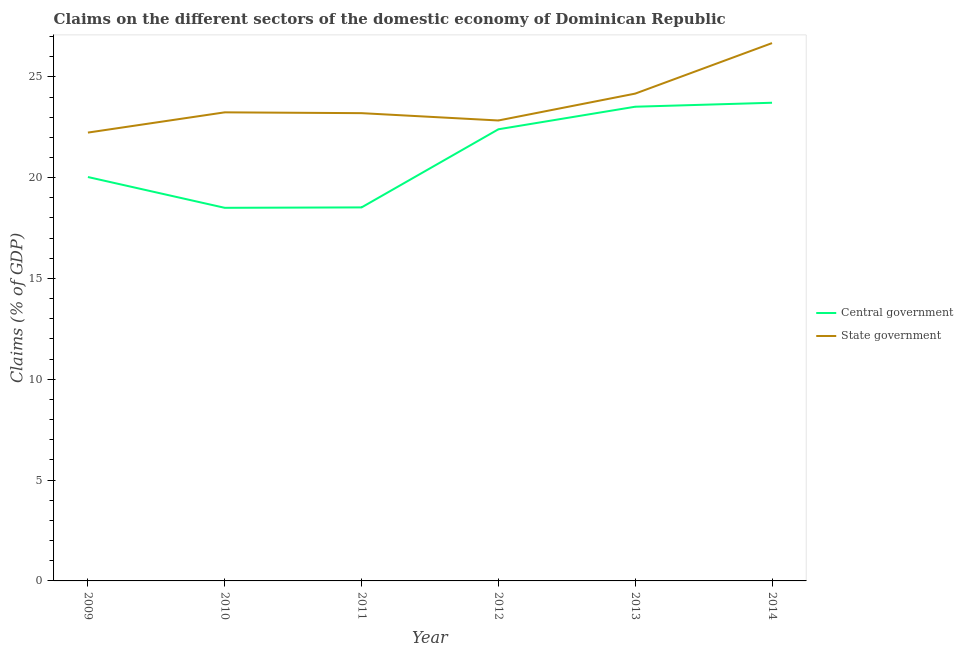Does the line corresponding to claims on central government intersect with the line corresponding to claims on state government?
Provide a short and direct response. No. Is the number of lines equal to the number of legend labels?
Your answer should be compact. Yes. What is the claims on central government in 2011?
Give a very brief answer. 18.52. Across all years, what is the maximum claims on central government?
Keep it short and to the point. 23.71. Across all years, what is the minimum claims on state government?
Your answer should be very brief. 22.24. What is the total claims on central government in the graph?
Your response must be concise. 126.69. What is the difference between the claims on central government in 2010 and that in 2011?
Provide a short and direct response. -0.02. What is the difference between the claims on central government in 2011 and the claims on state government in 2013?
Offer a terse response. -5.64. What is the average claims on state government per year?
Offer a very short reply. 23.73. In the year 2011, what is the difference between the claims on central government and claims on state government?
Give a very brief answer. -4.67. What is the ratio of the claims on central government in 2009 to that in 2013?
Give a very brief answer. 0.85. Is the claims on central government in 2012 less than that in 2014?
Provide a short and direct response. Yes. Is the difference between the claims on state government in 2009 and 2011 greater than the difference between the claims on central government in 2009 and 2011?
Keep it short and to the point. No. What is the difference between the highest and the second highest claims on central government?
Your answer should be very brief. 0.2. What is the difference between the highest and the lowest claims on central government?
Provide a short and direct response. 5.21. In how many years, is the claims on state government greater than the average claims on state government taken over all years?
Give a very brief answer. 2. Is the claims on state government strictly greater than the claims on central government over the years?
Your answer should be very brief. Yes. Is the claims on central government strictly less than the claims on state government over the years?
Offer a terse response. Yes. Are the values on the major ticks of Y-axis written in scientific E-notation?
Your answer should be compact. No. Does the graph contain any zero values?
Give a very brief answer. No. Where does the legend appear in the graph?
Keep it short and to the point. Center right. How many legend labels are there?
Your response must be concise. 2. How are the legend labels stacked?
Your response must be concise. Vertical. What is the title of the graph?
Offer a terse response. Claims on the different sectors of the domestic economy of Dominican Republic. Does "DAC donors" appear as one of the legend labels in the graph?
Keep it short and to the point. No. What is the label or title of the X-axis?
Keep it short and to the point. Year. What is the label or title of the Y-axis?
Give a very brief answer. Claims (% of GDP). What is the Claims (% of GDP) of Central government in 2009?
Keep it short and to the point. 20.03. What is the Claims (% of GDP) in State government in 2009?
Your answer should be very brief. 22.24. What is the Claims (% of GDP) in Central government in 2010?
Your answer should be very brief. 18.5. What is the Claims (% of GDP) of State government in 2010?
Offer a very short reply. 23.24. What is the Claims (% of GDP) of Central government in 2011?
Offer a terse response. 18.52. What is the Claims (% of GDP) of State government in 2011?
Your answer should be very brief. 23.2. What is the Claims (% of GDP) in Central government in 2012?
Keep it short and to the point. 22.4. What is the Claims (% of GDP) in State government in 2012?
Ensure brevity in your answer.  22.84. What is the Claims (% of GDP) in Central government in 2013?
Your answer should be compact. 23.52. What is the Claims (% of GDP) in State government in 2013?
Your response must be concise. 24.17. What is the Claims (% of GDP) in Central government in 2014?
Your answer should be very brief. 23.71. What is the Claims (% of GDP) in State government in 2014?
Your response must be concise. 26.67. Across all years, what is the maximum Claims (% of GDP) in Central government?
Provide a short and direct response. 23.71. Across all years, what is the maximum Claims (% of GDP) in State government?
Ensure brevity in your answer.  26.67. Across all years, what is the minimum Claims (% of GDP) in Central government?
Offer a very short reply. 18.5. Across all years, what is the minimum Claims (% of GDP) of State government?
Provide a short and direct response. 22.24. What is the total Claims (% of GDP) in Central government in the graph?
Give a very brief answer. 126.69. What is the total Claims (% of GDP) of State government in the graph?
Make the answer very short. 142.35. What is the difference between the Claims (% of GDP) of Central government in 2009 and that in 2010?
Offer a terse response. 1.53. What is the difference between the Claims (% of GDP) in State government in 2009 and that in 2010?
Your answer should be very brief. -1. What is the difference between the Claims (% of GDP) in Central government in 2009 and that in 2011?
Give a very brief answer. 1.51. What is the difference between the Claims (% of GDP) of State government in 2009 and that in 2011?
Provide a short and direct response. -0.96. What is the difference between the Claims (% of GDP) of Central government in 2009 and that in 2012?
Offer a terse response. -2.37. What is the difference between the Claims (% of GDP) of State government in 2009 and that in 2012?
Make the answer very short. -0.6. What is the difference between the Claims (% of GDP) of Central government in 2009 and that in 2013?
Make the answer very short. -3.49. What is the difference between the Claims (% of GDP) of State government in 2009 and that in 2013?
Offer a terse response. -1.93. What is the difference between the Claims (% of GDP) of Central government in 2009 and that in 2014?
Ensure brevity in your answer.  -3.68. What is the difference between the Claims (% of GDP) of State government in 2009 and that in 2014?
Offer a terse response. -4.44. What is the difference between the Claims (% of GDP) in Central government in 2010 and that in 2011?
Your answer should be compact. -0.02. What is the difference between the Claims (% of GDP) of State government in 2010 and that in 2011?
Offer a terse response. 0.04. What is the difference between the Claims (% of GDP) in Central government in 2010 and that in 2012?
Keep it short and to the point. -3.89. What is the difference between the Claims (% of GDP) in State government in 2010 and that in 2012?
Make the answer very short. 0.4. What is the difference between the Claims (% of GDP) in Central government in 2010 and that in 2013?
Make the answer very short. -5.01. What is the difference between the Claims (% of GDP) in State government in 2010 and that in 2013?
Your answer should be compact. -0.93. What is the difference between the Claims (% of GDP) of Central government in 2010 and that in 2014?
Your response must be concise. -5.21. What is the difference between the Claims (% of GDP) in State government in 2010 and that in 2014?
Make the answer very short. -3.43. What is the difference between the Claims (% of GDP) of Central government in 2011 and that in 2012?
Give a very brief answer. -3.87. What is the difference between the Claims (% of GDP) in State government in 2011 and that in 2012?
Make the answer very short. 0.36. What is the difference between the Claims (% of GDP) of Central government in 2011 and that in 2013?
Your response must be concise. -4.99. What is the difference between the Claims (% of GDP) in State government in 2011 and that in 2013?
Offer a very short reply. -0.97. What is the difference between the Claims (% of GDP) of Central government in 2011 and that in 2014?
Ensure brevity in your answer.  -5.19. What is the difference between the Claims (% of GDP) of State government in 2011 and that in 2014?
Make the answer very short. -3.47. What is the difference between the Claims (% of GDP) of Central government in 2012 and that in 2013?
Provide a short and direct response. -1.12. What is the difference between the Claims (% of GDP) in State government in 2012 and that in 2013?
Your answer should be very brief. -1.33. What is the difference between the Claims (% of GDP) in Central government in 2012 and that in 2014?
Keep it short and to the point. -1.32. What is the difference between the Claims (% of GDP) of State government in 2012 and that in 2014?
Provide a short and direct response. -3.84. What is the difference between the Claims (% of GDP) in Central government in 2013 and that in 2014?
Your response must be concise. -0.2. What is the difference between the Claims (% of GDP) of State government in 2013 and that in 2014?
Your answer should be very brief. -2.5. What is the difference between the Claims (% of GDP) in Central government in 2009 and the Claims (% of GDP) in State government in 2010?
Offer a very short reply. -3.21. What is the difference between the Claims (% of GDP) in Central government in 2009 and the Claims (% of GDP) in State government in 2011?
Give a very brief answer. -3.17. What is the difference between the Claims (% of GDP) of Central government in 2009 and the Claims (% of GDP) of State government in 2012?
Your response must be concise. -2.8. What is the difference between the Claims (% of GDP) of Central government in 2009 and the Claims (% of GDP) of State government in 2013?
Your answer should be very brief. -4.14. What is the difference between the Claims (% of GDP) in Central government in 2009 and the Claims (% of GDP) in State government in 2014?
Offer a terse response. -6.64. What is the difference between the Claims (% of GDP) in Central government in 2010 and the Claims (% of GDP) in State government in 2011?
Your answer should be very brief. -4.69. What is the difference between the Claims (% of GDP) in Central government in 2010 and the Claims (% of GDP) in State government in 2012?
Your response must be concise. -4.33. What is the difference between the Claims (% of GDP) in Central government in 2010 and the Claims (% of GDP) in State government in 2013?
Your answer should be compact. -5.66. What is the difference between the Claims (% of GDP) of Central government in 2010 and the Claims (% of GDP) of State government in 2014?
Keep it short and to the point. -8.17. What is the difference between the Claims (% of GDP) of Central government in 2011 and the Claims (% of GDP) of State government in 2012?
Your response must be concise. -4.31. What is the difference between the Claims (% of GDP) of Central government in 2011 and the Claims (% of GDP) of State government in 2013?
Ensure brevity in your answer.  -5.64. What is the difference between the Claims (% of GDP) in Central government in 2011 and the Claims (% of GDP) in State government in 2014?
Ensure brevity in your answer.  -8.15. What is the difference between the Claims (% of GDP) in Central government in 2012 and the Claims (% of GDP) in State government in 2013?
Your answer should be very brief. -1.77. What is the difference between the Claims (% of GDP) of Central government in 2012 and the Claims (% of GDP) of State government in 2014?
Provide a succinct answer. -4.27. What is the difference between the Claims (% of GDP) of Central government in 2013 and the Claims (% of GDP) of State government in 2014?
Your answer should be very brief. -3.15. What is the average Claims (% of GDP) in Central government per year?
Give a very brief answer. 21.12. What is the average Claims (% of GDP) in State government per year?
Provide a short and direct response. 23.73. In the year 2009, what is the difference between the Claims (% of GDP) in Central government and Claims (% of GDP) in State government?
Your answer should be very brief. -2.2. In the year 2010, what is the difference between the Claims (% of GDP) in Central government and Claims (% of GDP) in State government?
Your response must be concise. -4.74. In the year 2011, what is the difference between the Claims (% of GDP) in Central government and Claims (% of GDP) in State government?
Provide a short and direct response. -4.67. In the year 2012, what is the difference between the Claims (% of GDP) in Central government and Claims (% of GDP) in State government?
Offer a very short reply. -0.44. In the year 2013, what is the difference between the Claims (% of GDP) in Central government and Claims (% of GDP) in State government?
Your answer should be compact. -0.65. In the year 2014, what is the difference between the Claims (% of GDP) in Central government and Claims (% of GDP) in State government?
Make the answer very short. -2.96. What is the ratio of the Claims (% of GDP) of Central government in 2009 to that in 2010?
Give a very brief answer. 1.08. What is the ratio of the Claims (% of GDP) of State government in 2009 to that in 2010?
Offer a terse response. 0.96. What is the ratio of the Claims (% of GDP) of Central government in 2009 to that in 2011?
Your response must be concise. 1.08. What is the ratio of the Claims (% of GDP) of State government in 2009 to that in 2011?
Provide a short and direct response. 0.96. What is the ratio of the Claims (% of GDP) in Central government in 2009 to that in 2012?
Ensure brevity in your answer.  0.89. What is the ratio of the Claims (% of GDP) of State government in 2009 to that in 2012?
Provide a short and direct response. 0.97. What is the ratio of the Claims (% of GDP) of Central government in 2009 to that in 2013?
Offer a very short reply. 0.85. What is the ratio of the Claims (% of GDP) of Central government in 2009 to that in 2014?
Make the answer very short. 0.84. What is the ratio of the Claims (% of GDP) of State government in 2009 to that in 2014?
Offer a very short reply. 0.83. What is the ratio of the Claims (% of GDP) of Central government in 2010 to that in 2012?
Give a very brief answer. 0.83. What is the ratio of the Claims (% of GDP) of State government in 2010 to that in 2012?
Your answer should be compact. 1.02. What is the ratio of the Claims (% of GDP) in Central government in 2010 to that in 2013?
Provide a short and direct response. 0.79. What is the ratio of the Claims (% of GDP) of State government in 2010 to that in 2013?
Your response must be concise. 0.96. What is the ratio of the Claims (% of GDP) of Central government in 2010 to that in 2014?
Offer a very short reply. 0.78. What is the ratio of the Claims (% of GDP) of State government in 2010 to that in 2014?
Your answer should be compact. 0.87. What is the ratio of the Claims (% of GDP) of Central government in 2011 to that in 2012?
Offer a very short reply. 0.83. What is the ratio of the Claims (% of GDP) of State government in 2011 to that in 2012?
Make the answer very short. 1.02. What is the ratio of the Claims (% of GDP) in Central government in 2011 to that in 2013?
Keep it short and to the point. 0.79. What is the ratio of the Claims (% of GDP) in State government in 2011 to that in 2013?
Your response must be concise. 0.96. What is the ratio of the Claims (% of GDP) of Central government in 2011 to that in 2014?
Provide a short and direct response. 0.78. What is the ratio of the Claims (% of GDP) in State government in 2011 to that in 2014?
Make the answer very short. 0.87. What is the ratio of the Claims (% of GDP) in Central government in 2012 to that in 2013?
Your answer should be compact. 0.95. What is the ratio of the Claims (% of GDP) of State government in 2012 to that in 2013?
Make the answer very short. 0.94. What is the ratio of the Claims (% of GDP) of Central government in 2012 to that in 2014?
Your answer should be very brief. 0.94. What is the ratio of the Claims (% of GDP) in State government in 2012 to that in 2014?
Give a very brief answer. 0.86. What is the ratio of the Claims (% of GDP) of State government in 2013 to that in 2014?
Offer a very short reply. 0.91. What is the difference between the highest and the second highest Claims (% of GDP) in Central government?
Keep it short and to the point. 0.2. What is the difference between the highest and the second highest Claims (% of GDP) in State government?
Give a very brief answer. 2.5. What is the difference between the highest and the lowest Claims (% of GDP) of Central government?
Make the answer very short. 5.21. What is the difference between the highest and the lowest Claims (% of GDP) of State government?
Offer a terse response. 4.44. 